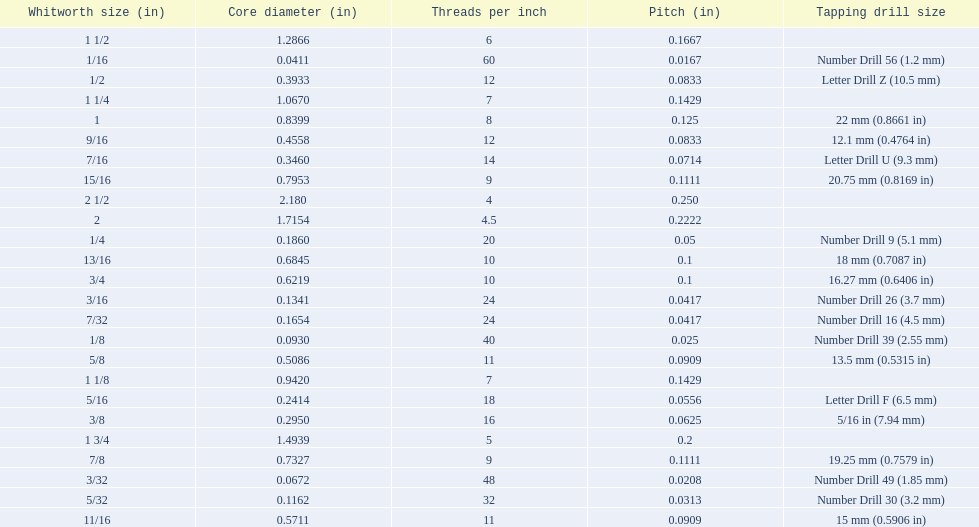A 1/16 whitworth has a core diameter of? 0.0411. Which whiteworth size has the same pitch as a 1/2? 9/16. 3/16 whiteworth has the same number of threads as? 7/32. 